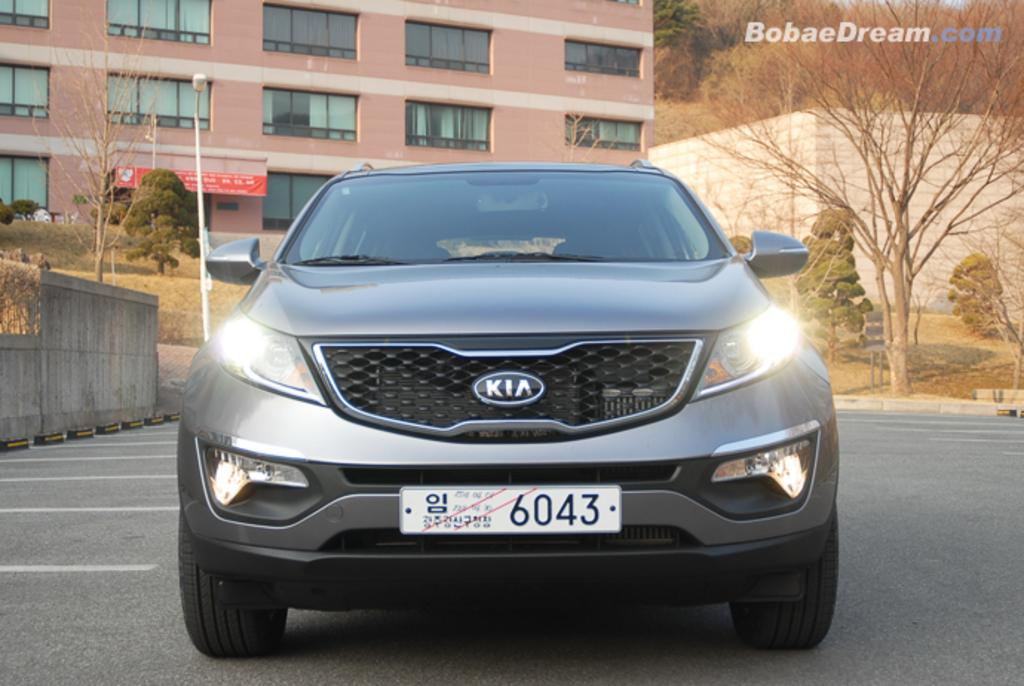What is the main subject in the center of the image? There is a car in the center of the image. What can be seen in the background of the image? There is a building, trees, a wall, a pole, grass, and a wooden fence in the background of the image. What is at the bottom of the image? There is a road at the bottom of the image. What type of friction can be observed between the car and the home in the image? There is no home present in the image, and therefore no friction can be observed between the car and a home. 